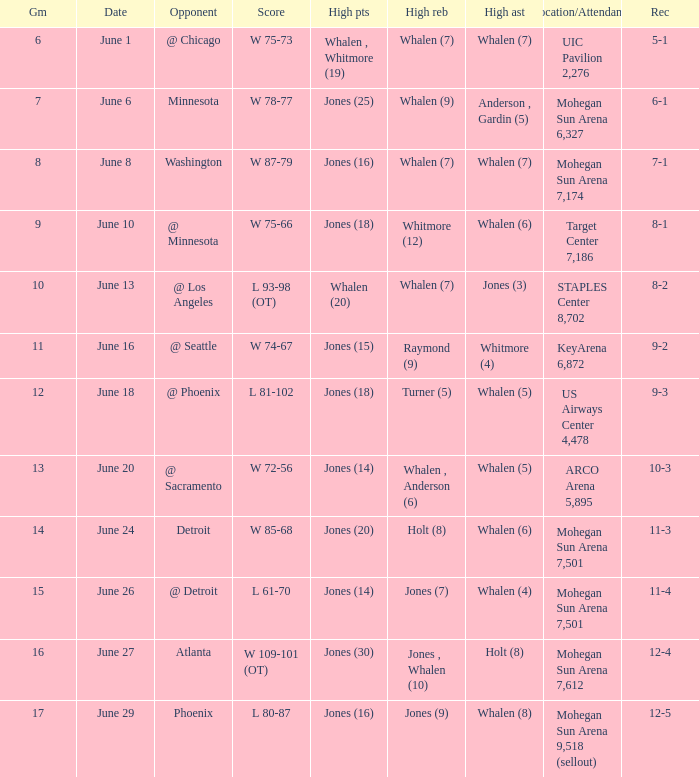What is the location/attendance when the record is 9-2? KeyArena 6,872. 